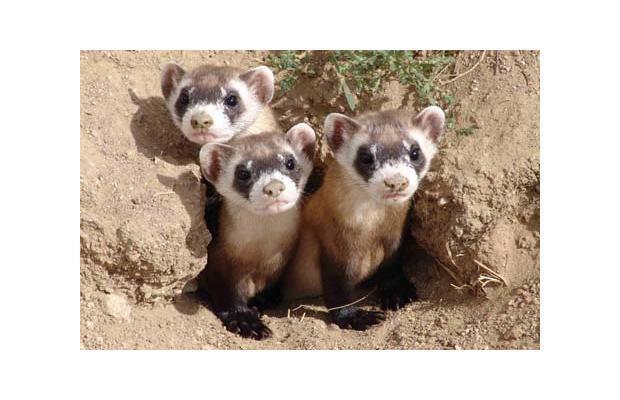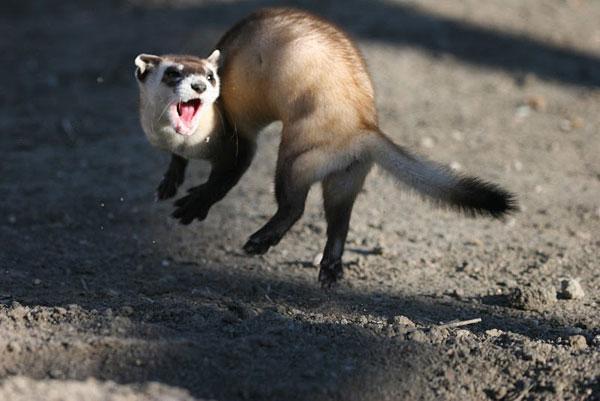The first image is the image on the left, the second image is the image on the right. Considering the images on both sides, is "There are four ferrets" valid? Answer yes or no. Yes. The first image is the image on the left, the second image is the image on the right. Given the left and right images, does the statement "An image shows three ferrets, which are looking forward with heads up." hold true? Answer yes or no. Yes. 